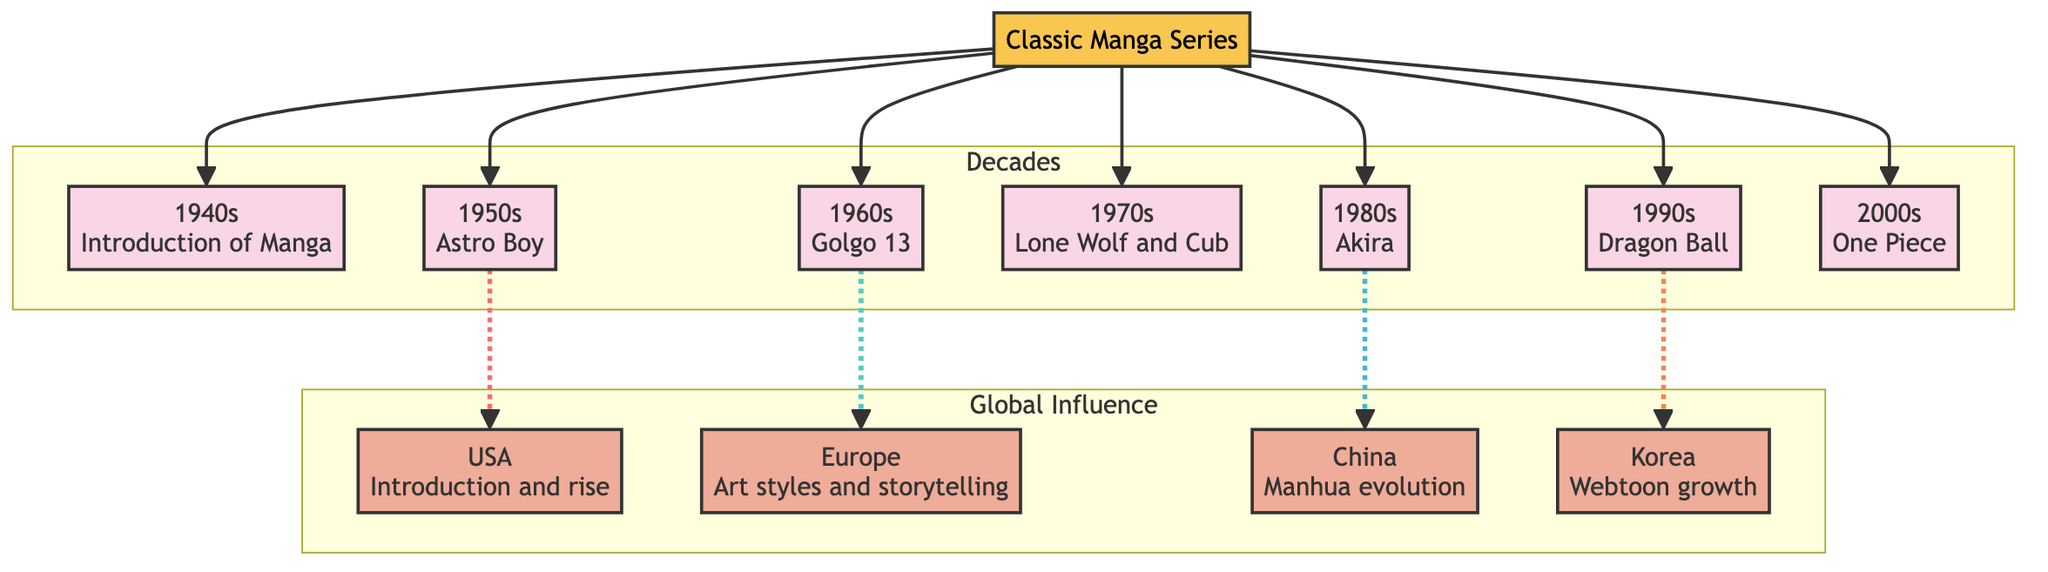What manga series began in the 1980s? The diagram shows the decades with associated classic manga series. The decade indicated by the 1980s node is linked to the title "Akira."
Answer: Akira Which country experienced the introduction of manga in the 1950s? The diagram connects the 1950s node with the USA node through a dashed line. This indicates that the USA recognized the influence of manga in that decade.
Answer: USA How many decades are represented in the diagram? By counting the individual decade nodes in the "Decades" subgraph, we find there are a total of seven decades represented.
Answer: 7 Which decade shows the influence of manga on European art styles? The diagram links Europe to the 1960s decade with a dashed line, indicating the influence of manga on European comic art during that time.
Answer: 1960s What was the major manga series linked to the 1990s? The 1990s node in the diagram is connected to the title "Dragon Ball," which indicates that this series was significant during that decade.
Answer: Dragon Ball Which decade is associated with the growth of webtoons in Korea? The reasoning follows the dashed line from the 1990s node to the Korea node, indicating that the influence from manga began to foster the growth of webtoons in Korea during this decade.
Answer: 1990s Which country is associated with manhua evolution? The diagram shows a connection between the 1980s node (Akira) and the China node, indicating that this period contributed to the evolution of manhua.
Answer: China What type of linkage is used for the influence from the 1950s to the USA? The diagram utilizes a dashed line to represent the influence between the 1950s decade node and the USA node, suggesting a less direct, conceptual connection rather than a direct influence.
Answer: Dashed line What color represents classic manga series in the diagram? The diagram specifies the color fill for the classic manga series node as #f9c74f, which visually distinguishes it from the other elements within the diagram.
Answer: #f9c74f 